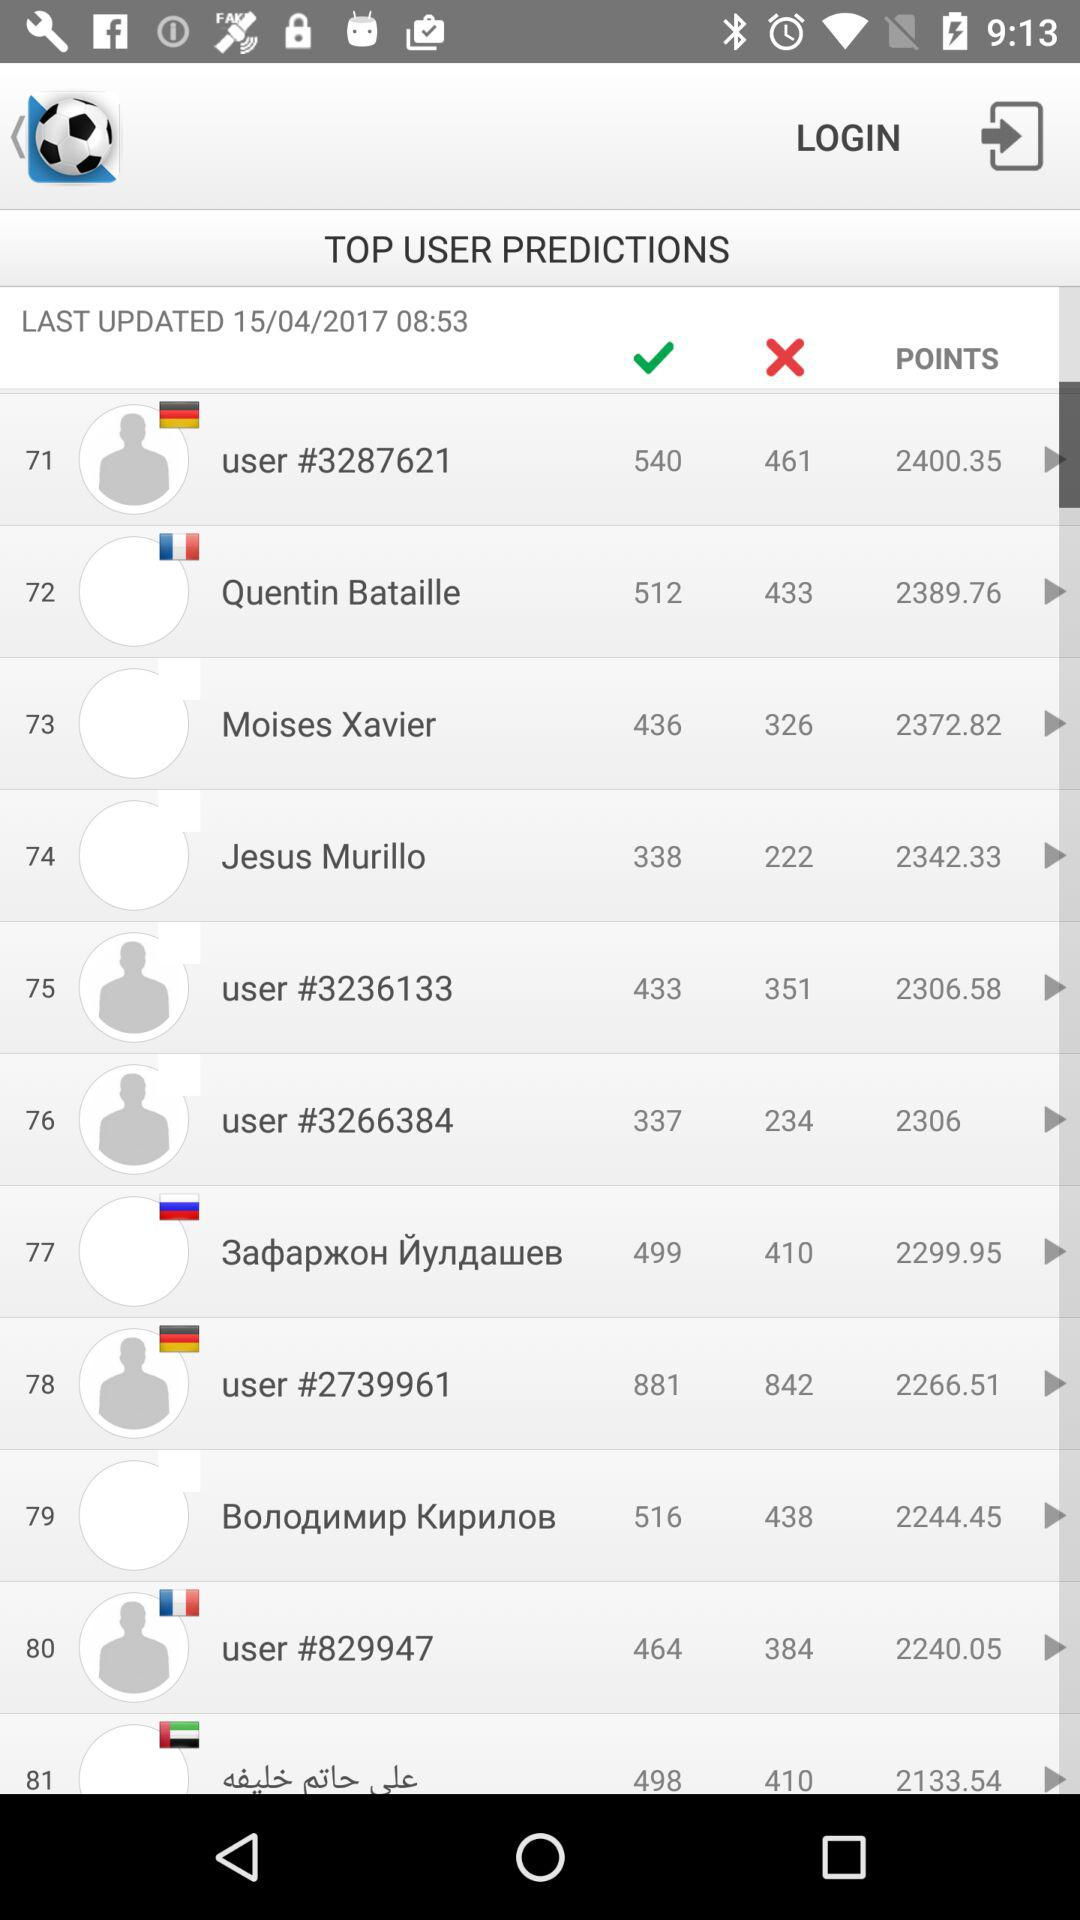What is the last updated date of the Top User Predictions? The last updated date of the Top User Predictions is 15/04/2017. 